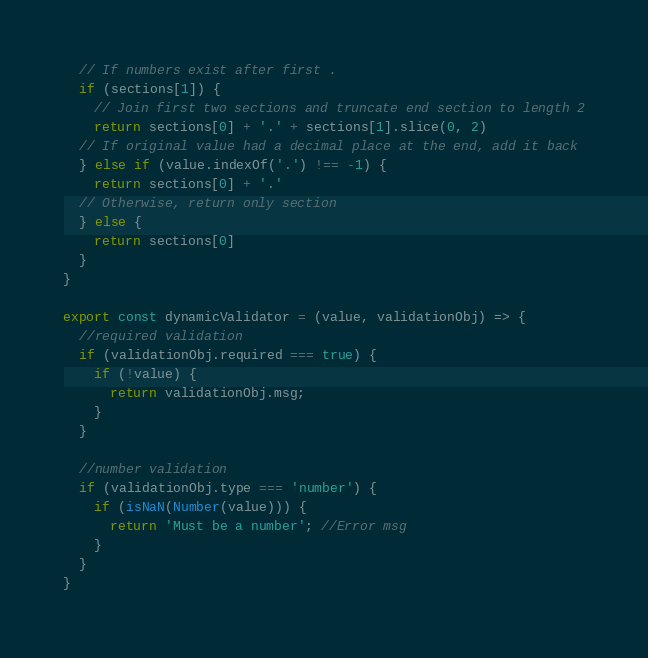<code> <loc_0><loc_0><loc_500><loc_500><_JavaScript_>  // If numbers exist after first .
  if (sections[1]) {
    // Join first two sections and truncate end section to length 2
    return sections[0] + '.' + sections[1].slice(0, 2)
  // If original value had a decimal place at the end, add it back
  } else if (value.indexOf('.') !== -1) {
    return sections[0] + '.'
  // Otherwise, return only section
  } else {
    return sections[0]
  }
}

export const dynamicValidator = (value, validationObj) => {
  //required validation
  if (validationObj.required === true) {
    if (!value) {
      return validationObj.msg;
    }
  }

  //number validation
  if (validationObj.type === 'number') {
    if (isNaN(Number(value))) {
      return 'Must be a number'; //Error msg
    }
  }   
}
</code> 